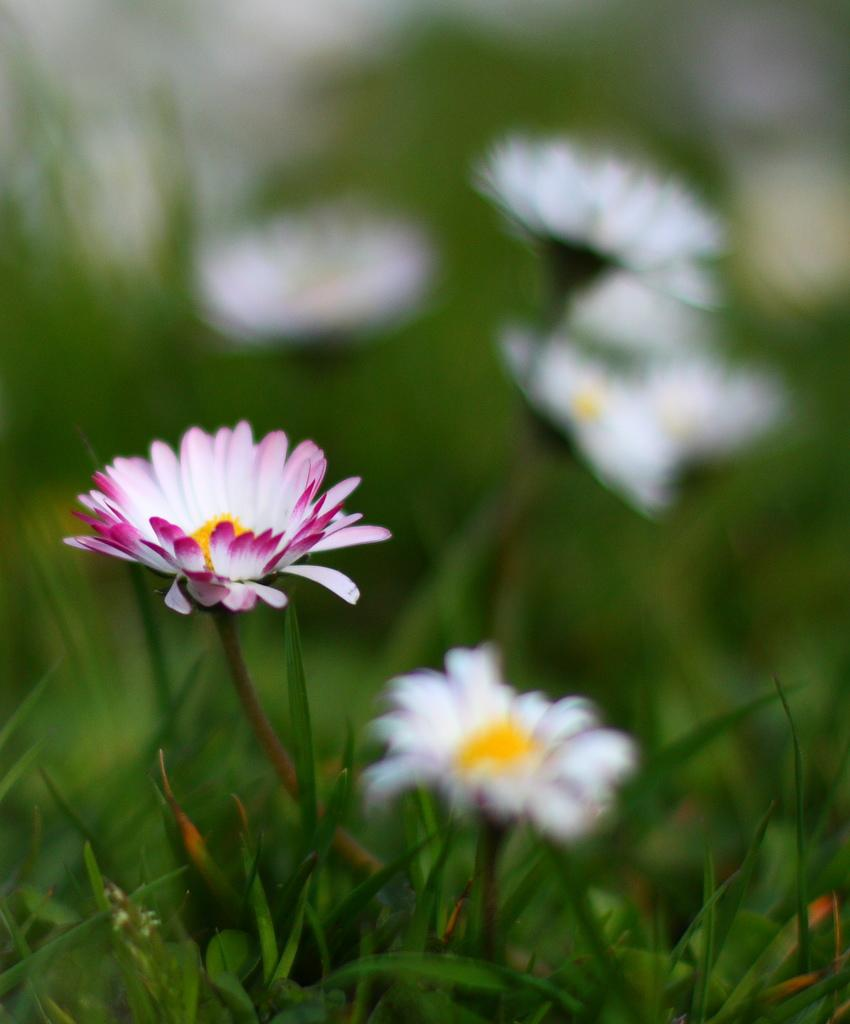What type of plants can be seen in the image? There are plants with flowers in the image. What can be observed about the background of the image? The background of the image is blurred. What specific part of the plants is visible in the image? Flowers are visible in the image. What color is the sheet draped over the throat of the plant in the image? There is no sheet or throat present in the image; it features plants with flowers and a blurred background. 